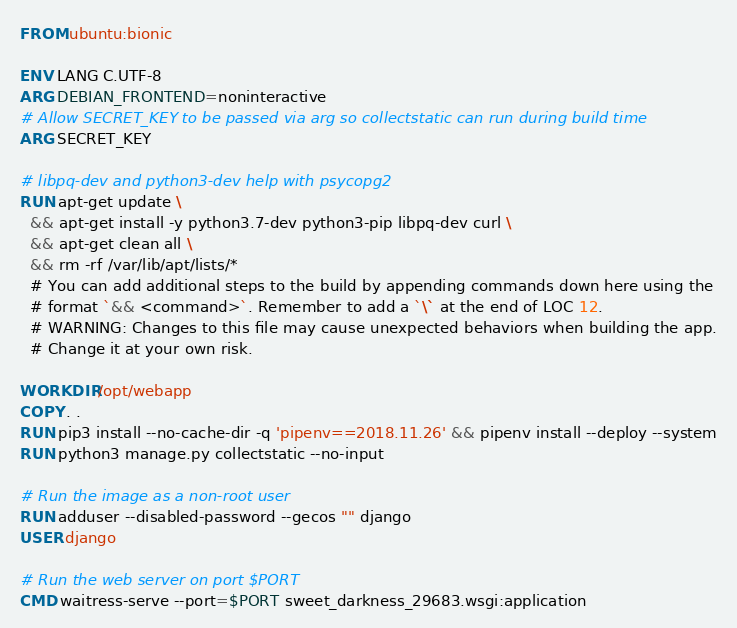<code> <loc_0><loc_0><loc_500><loc_500><_Dockerfile_>FROM ubuntu:bionic

ENV LANG C.UTF-8
ARG DEBIAN_FRONTEND=noninteractive
# Allow SECRET_KEY to be passed via arg so collectstatic can run during build time
ARG SECRET_KEY

# libpq-dev and python3-dev help with psycopg2
RUN apt-get update \
  && apt-get install -y python3.7-dev python3-pip libpq-dev curl \
  && apt-get clean all \
  && rm -rf /var/lib/apt/lists/*
  # You can add additional steps to the build by appending commands down here using the
  # format `&& <command>`. Remember to add a `\` at the end of LOC 12.
  # WARNING: Changes to this file may cause unexpected behaviors when building the app.
  # Change it at your own risk.

WORKDIR /opt/webapp
COPY . .
RUN pip3 install --no-cache-dir -q 'pipenv==2018.11.26' && pipenv install --deploy --system
RUN python3 manage.py collectstatic --no-input

# Run the image as a non-root user
RUN adduser --disabled-password --gecos "" django
USER django

# Run the web server on port $PORT
CMD waitress-serve --port=$PORT sweet_darkness_29683.wsgi:application
</code> 